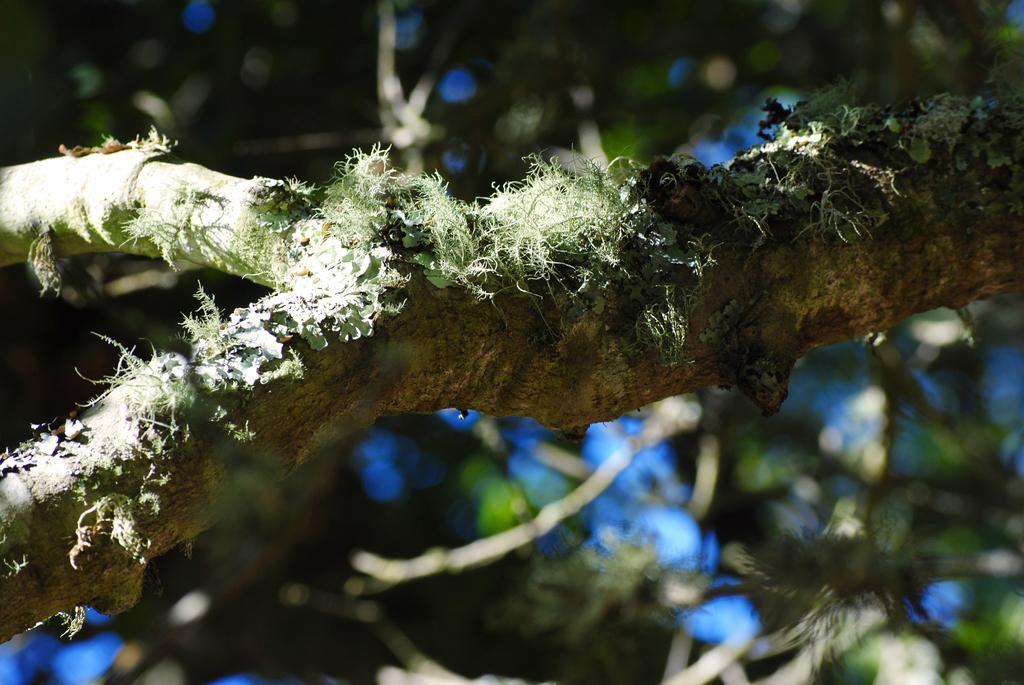In one or two sentences, can you explain what this image depicts? In this picture we can see branches and leaves. In the background of the image it is blurry. 